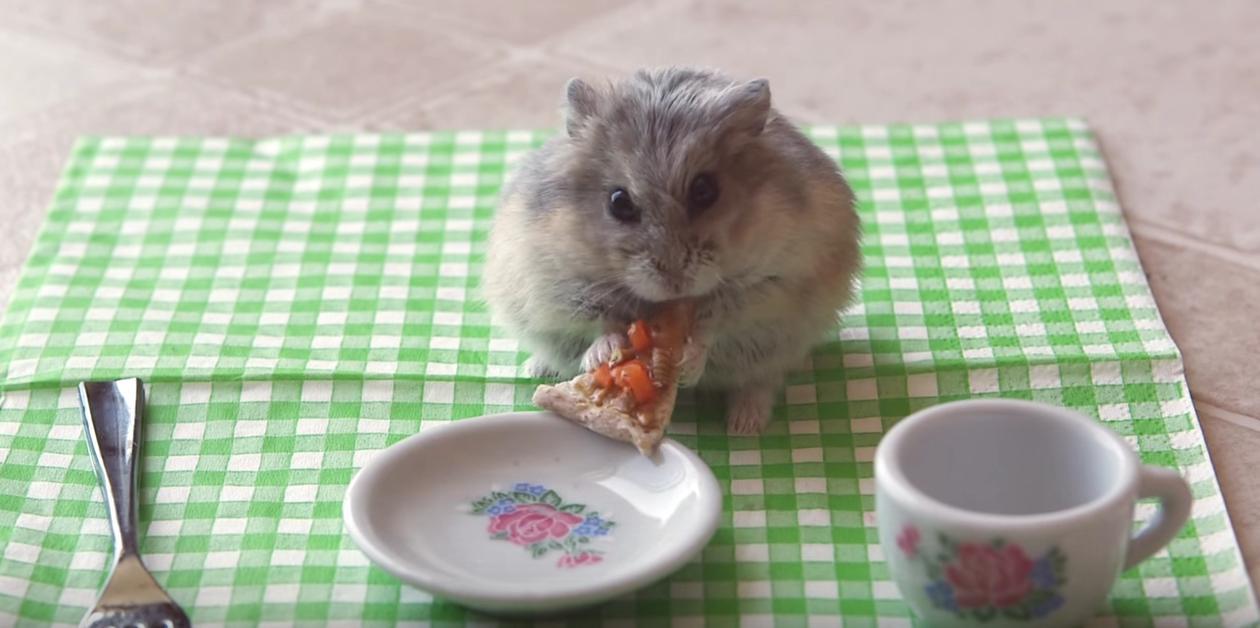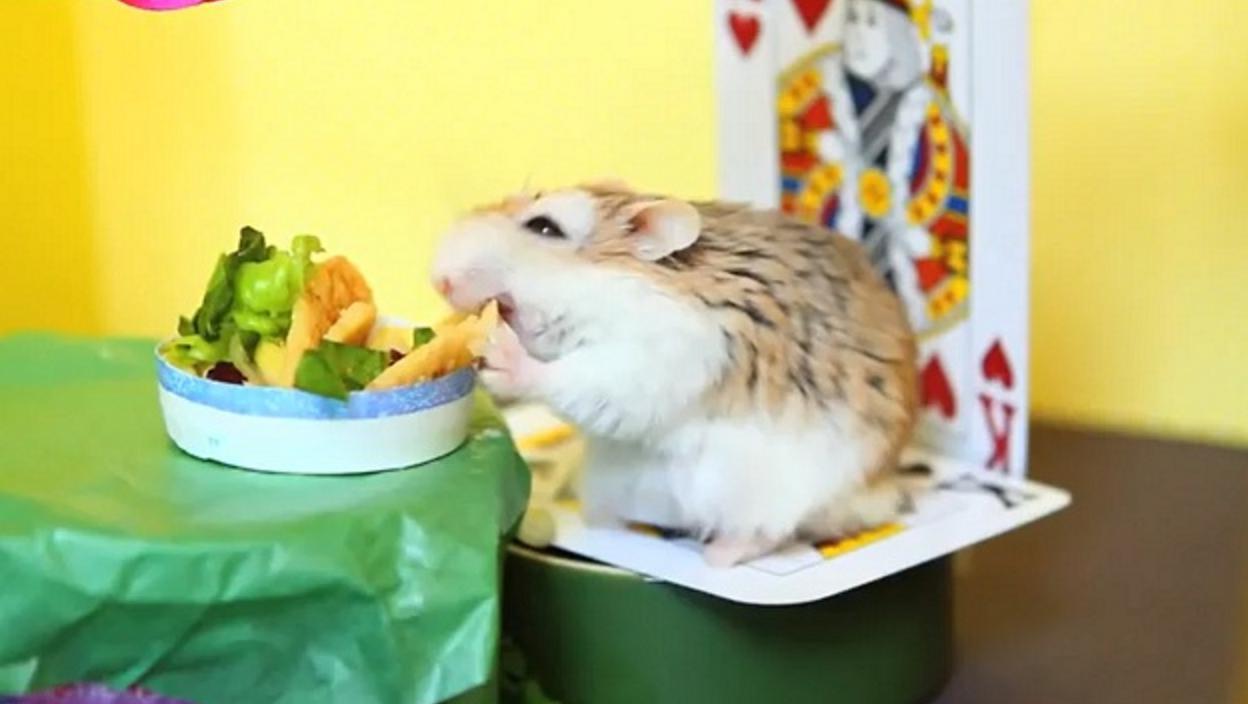The first image is the image on the left, the second image is the image on the right. Examine the images to the left and right. Is the description "An image shows a hamster eating at a green """"table"""" that holds a poker chip """"dish"""" with white notch marks around its edge." accurate? Answer yes or no. No. 